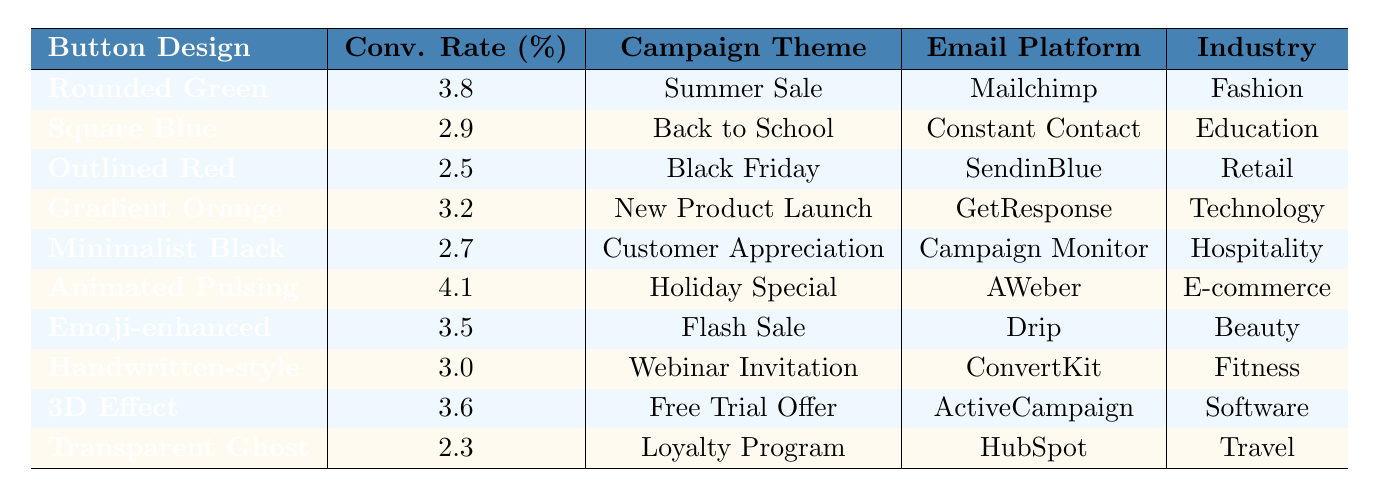What is the conversion rate for the Animated Pulsing Button? The conversion rate for the Animated Pulsing Button is listed directly in the table under the "Conv. Rate (%)" column, which is 4.1%.
Answer: 4.1% Which button design has the lowest conversion rate? Upon checking the "Conv. Rate (%)" column, the Transparent Ghost Button has the lowest conversion rate at 2.3%.
Answer: Transparent Ghost Button What is the conversion rate difference between the Rounded Green Button and the Square Blue Button? The conversion rate for the Rounded Green Button is 3.8%, while the Square Blue Button is 2.9%. The difference is calculated as 3.8 - 2.9 = 0.9.
Answer: 0.9 What is the highest conversion rate among the button designs? Looking at the "Conv. Rate (%)" column, the highest conversion rate is 4.1%, associated with the Animated Pulsing Button.
Answer: 4.1% If we combine the conversion rates of the Emoji-enhanced Button and the 3D Effect Button, what is their total? The conversion rate for the Emoji-enhanced Button is 3.5% and for the 3D Effect Button is 3.6%. Their total is 3.5 + 3.6 = 7.1%.
Answer: 7.1% Which campaign theme corresponds to the highest conversion rate button design? The Animated Pulsing Button has the highest conversion rate of 4.1%, and the corresponding campaign theme is "Holiday Special."
Answer: Holiday Special Is there any button design used in the 'Travel' industry that has a conversion rate over 3%? The only button design related to the Travel industry is the Transparent Ghost Button, which has a conversion rate of 2.3%, which is below 3%. Therefore, the answer is no.
Answer: No Which button design has a conversion rate equal to or greater than 3% but is not associated with an E-commerce industry? The Rounded Green Button (3.8%) and 3D Effect Button (3.6%) both meet this criterion and are not associated with E-commerce.
Answer: Rounded Green Button, 3D Effect Button What are the two campaign themes that have button designs with conversion rates below 3%? The two campaign themes are "Back to School" (Square Blue Button, 2.9%) and "Loyalty Program" (Transparent Ghost Button, 2.3%).
Answer: Back to School, Loyalty Program What conclusions can be drawn regarding the effectiveness of button designs across different industries? The Animated Pulsing Button has the highest conversion rate (4.1%), suggesting that animated designs may perform better in terms of engagement. Other designs have varied performance across industries, indicating that industry context matters.
Answer: Animated designs may be more effective 